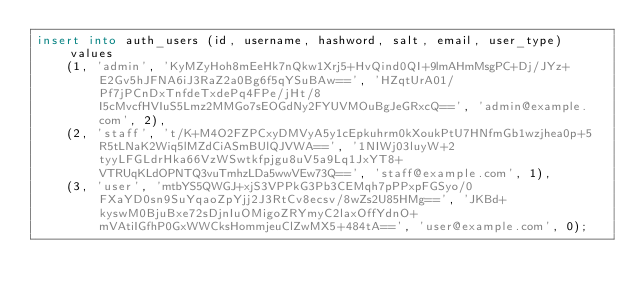<code> <loc_0><loc_0><loc_500><loc_500><_SQL_>insert into auth_users (id, username, hashword, salt, email, user_type) values
	(1, 'admin', 'KyMZyHoh8mEeHk7nQkw1Xrj5+HvQind0QI+9lmAHmMsgPC+Dj/JYz+E2Gv5hJFNA6iJ3RaZ2a0Bg6f5qYSuBAw==', 'HZqtUrA01/Pf7jPCnDxTnfdeTxdePq4FPe/jHt/8I5cMvcfHVIuS5Lmz2MMGo7sEOGdNy2FYUVMOuBgJeGRxcQ==', 'admin@example.com', 2),
	(2, 'staff', 't/K+M4O2FZPCxyDMVyA5y1cEpkuhrm0kXoukPtU7HNfmGb1wzjhea0p+5R5tLNaK2Wiq5lMZdCiASmBUlQJVWA==', '1NIWj03luyW+2tyyLFGLdrHka66VzWSwtkfpjgu8uV5a9Lq1JxYT8+VTRUqKLdOPNTQ3vuTmhzLDa5wwVEw73Q==', 'staff@example.com', 1),
	(3, 'user', 'mtbYS5QWGJ+xjS3VPPkG3Pb3CEMqh7pPPxpFGSyo/0FXaYD0sn9SuYqaoZpYjj2J3RtCv8ecsv/8wZs2U85HMg==', 'JKBd+kyswM0BjuBxe72sDjnIuOMigoZRYmyC2laxOffYdnO+mVAtiIGfhP0GxWWCksHommjeuClZwMX5+484tA==', 'user@example.com', 0);
</code> 